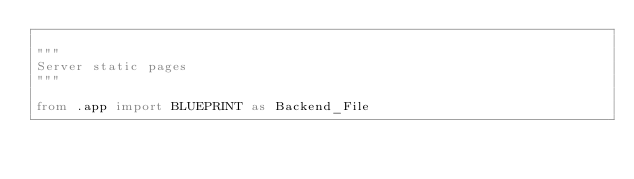Convert code to text. <code><loc_0><loc_0><loc_500><loc_500><_Python_>
"""
Server static pages
"""

from .app import BLUEPRINT as Backend_File
</code> 